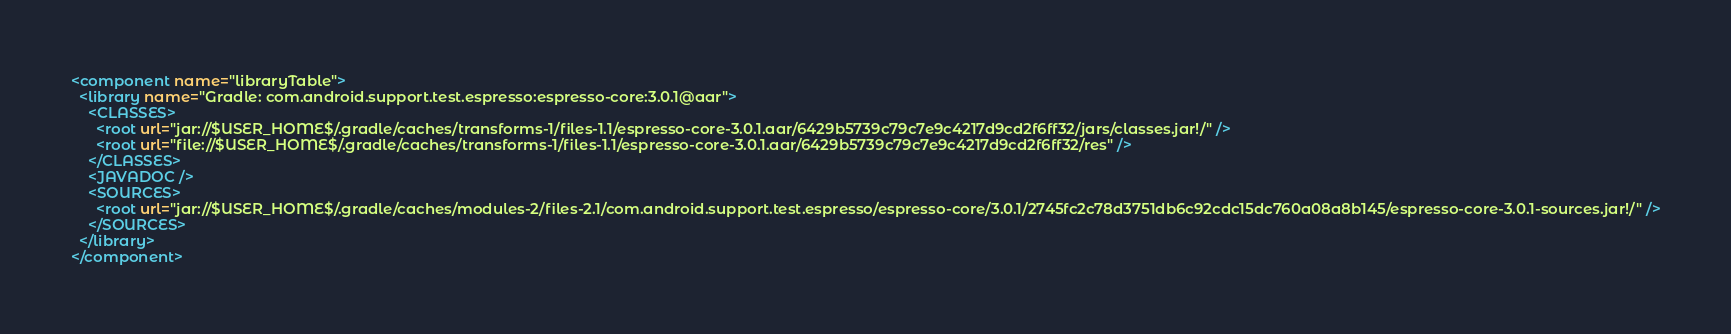<code> <loc_0><loc_0><loc_500><loc_500><_XML_><component name="libraryTable">
  <library name="Gradle: com.android.support.test.espresso:espresso-core:3.0.1@aar">
    <CLASSES>
      <root url="jar://$USER_HOME$/.gradle/caches/transforms-1/files-1.1/espresso-core-3.0.1.aar/6429b5739c79c7e9c4217d9cd2f6ff32/jars/classes.jar!/" />
      <root url="file://$USER_HOME$/.gradle/caches/transforms-1/files-1.1/espresso-core-3.0.1.aar/6429b5739c79c7e9c4217d9cd2f6ff32/res" />
    </CLASSES>
    <JAVADOC />
    <SOURCES>
      <root url="jar://$USER_HOME$/.gradle/caches/modules-2/files-2.1/com.android.support.test.espresso/espresso-core/3.0.1/2745fc2c78d3751db6c92cdc15dc760a08a8b145/espresso-core-3.0.1-sources.jar!/" />
    </SOURCES>
  </library>
</component></code> 